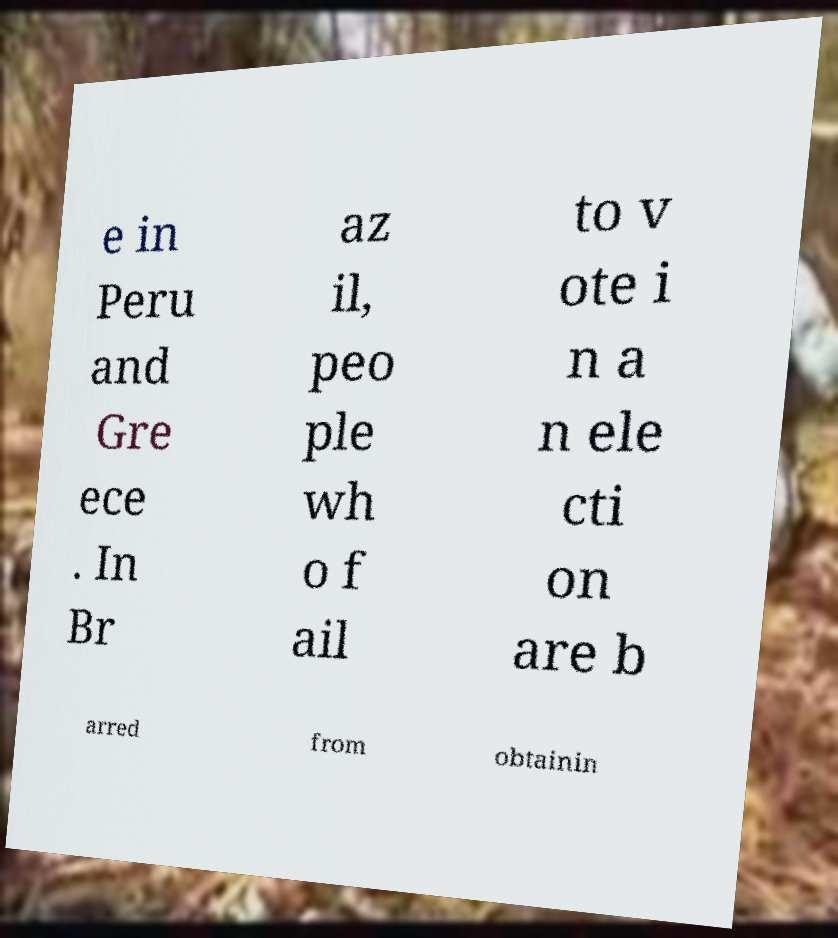Please read and relay the text visible in this image. What does it say? e in Peru and Gre ece . In Br az il, peo ple wh o f ail to v ote i n a n ele cti on are b arred from obtainin 